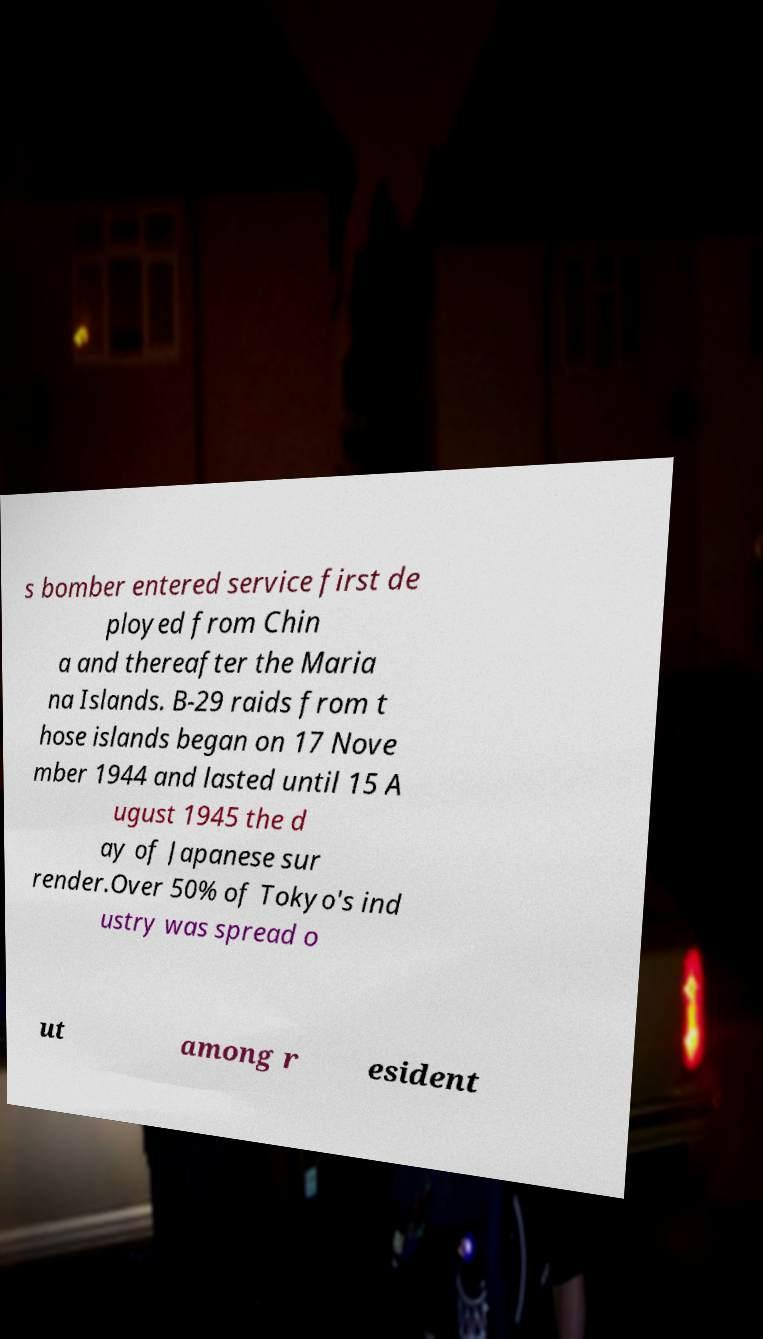Could you extract and type out the text from this image? s bomber entered service first de ployed from Chin a and thereafter the Maria na Islands. B-29 raids from t hose islands began on 17 Nove mber 1944 and lasted until 15 A ugust 1945 the d ay of Japanese sur render.Over 50% of Tokyo's ind ustry was spread o ut among r esident 